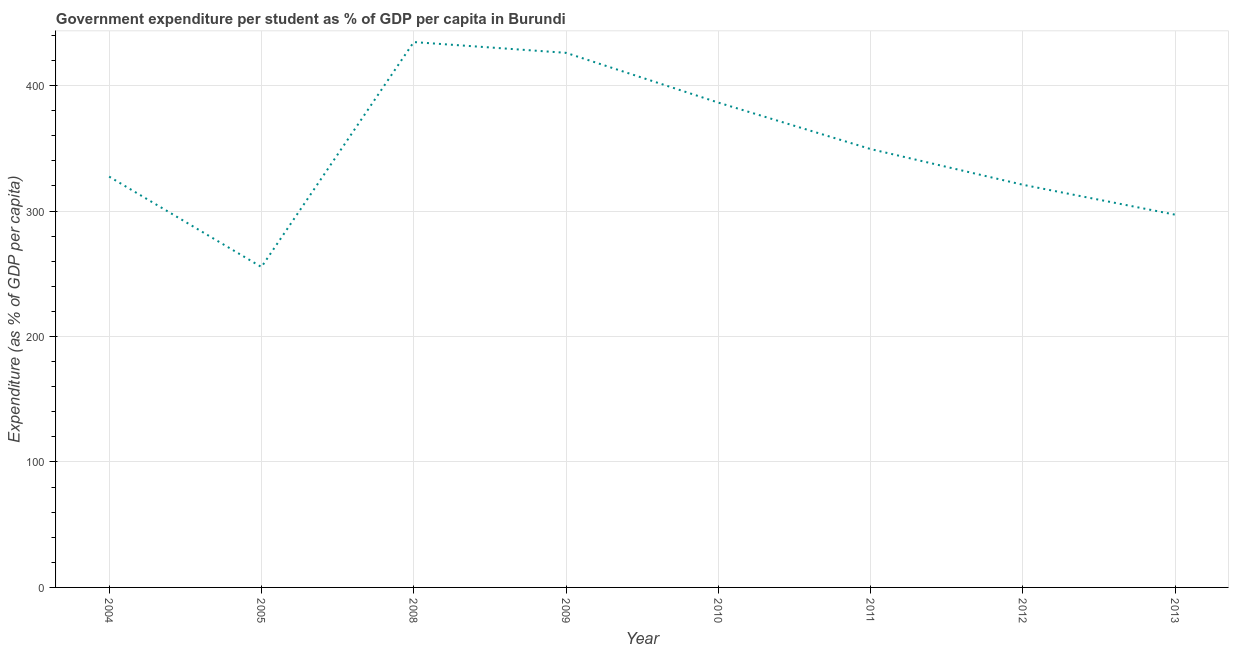What is the government expenditure per student in 2008?
Provide a short and direct response. 434.66. Across all years, what is the maximum government expenditure per student?
Provide a short and direct response. 434.66. Across all years, what is the minimum government expenditure per student?
Provide a succinct answer. 255.38. In which year was the government expenditure per student maximum?
Your answer should be very brief. 2008. In which year was the government expenditure per student minimum?
Give a very brief answer. 2005. What is the sum of the government expenditure per student?
Give a very brief answer. 2797.35. What is the difference between the government expenditure per student in 2008 and 2012?
Keep it short and to the point. 113.75. What is the average government expenditure per student per year?
Ensure brevity in your answer.  349.67. What is the median government expenditure per student?
Give a very brief answer. 338.41. In how many years, is the government expenditure per student greater than 20 %?
Your answer should be very brief. 8. Do a majority of the years between 2013 and 2010 (inclusive) have government expenditure per student greater than 160 %?
Your answer should be very brief. Yes. What is the ratio of the government expenditure per student in 2005 to that in 2008?
Give a very brief answer. 0.59. Is the government expenditure per student in 2004 less than that in 2008?
Give a very brief answer. Yes. Is the difference between the government expenditure per student in 2004 and 2012 greater than the difference between any two years?
Provide a succinct answer. No. What is the difference between the highest and the second highest government expenditure per student?
Your response must be concise. 8.58. What is the difference between the highest and the lowest government expenditure per student?
Your response must be concise. 179.28. In how many years, is the government expenditure per student greater than the average government expenditure per student taken over all years?
Provide a succinct answer. 3. Does the government expenditure per student monotonically increase over the years?
Ensure brevity in your answer.  No. How many years are there in the graph?
Offer a terse response. 8. What is the difference between two consecutive major ticks on the Y-axis?
Keep it short and to the point. 100. Are the values on the major ticks of Y-axis written in scientific E-notation?
Your answer should be very brief. No. Does the graph contain any zero values?
Make the answer very short. No. Does the graph contain grids?
Make the answer very short. Yes. What is the title of the graph?
Ensure brevity in your answer.  Government expenditure per student as % of GDP per capita in Burundi. What is the label or title of the Y-axis?
Your answer should be very brief. Expenditure (as % of GDP per capita). What is the Expenditure (as % of GDP per capita) in 2004?
Your answer should be very brief. 327.42. What is the Expenditure (as % of GDP per capita) of 2005?
Offer a terse response. 255.38. What is the Expenditure (as % of GDP per capita) of 2008?
Your response must be concise. 434.66. What is the Expenditure (as % of GDP per capita) in 2009?
Provide a succinct answer. 426.08. What is the Expenditure (as % of GDP per capita) in 2010?
Provide a succinct answer. 386.42. What is the Expenditure (as % of GDP per capita) in 2011?
Give a very brief answer. 349.39. What is the Expenditure (as % of GDP per capita) of 2012?
Provide a short and direct response. 320.91. What is the Expenditure (as % of GDP per capita) of 2013?
Provide a short and direct response. 297.08. What is the difference between the Expenditure (as % of GDP per capita) in 2004 and 2005?
Provide a short and direct response. 72.04. What is the difference between the Expenditure (as % of GDP per capita) in 2004 and 2008?
Your response must be concise. -107.24. What is the difference between the Expenditure (as % of GDP per capita) in 2004 and 2009?
Ensure brevity in your answer.  -98.66. What is the difference between the Expenditure (as % of GDP per capita) in 2004 and 2010?
Offer a terse response. -59. What is the difference between the Expenditure (as % of GDP per capita) in 2004 and 2011?
Give a very brief answer. -21.96. What is the difference between the Expenditure (as % of GDP per capita) in 2004 and 2012?
Keep it short and to the point. 6.51. What is the difference between the Expenditure (as % of GDP per capita) in 2004 and 2013?
Make the answer very short. 30.34. What is the difference between the Expenditure (as % of GDP per capita) in 2005 and 2008?
Offer a terse response. -179.28. What is the difference between the Expenditure (as % of GDP per capita) in 2005 and 2009?
Your response must be concise. -170.7. What is the difference between the Expenditure (as % of GDP per capita) in 2005 and 2010?
Your answer should be compact. -131.04. What is the difference between the Expenditure (as % of GDP per capita) in 2005 and 2011?
Offer a very short reply. -94.01. What is the difference between the Expenditure (as % of GDP per capita) in 2005 and 2012?
Offer a very short reply. -65.53. What is the difference between the Expenditure (as % of GDP per capita) in 2005 and 2013?
Your response must be concise. -41.7. What is the difference between the Expenditure (as % of GDP per capita) in 2008 and 2009?
Offer a very short reply. 8.58. What is the difference between the Expenditure (as % of GDP per capita) in 2008 and 2010?
Make the answer very short. 48.24. What is the difference between the Expenditure (as % of GDP per capita) in 2008 and 2011?
Ensure brevity in your answer.  85.27. What is the difference between the Expenditure (as % of GDP per capita) in 2008 and 2012?
Keep it short and to the point. 113.75. What is the difference between the Expenditure (as % of GDP per capita) in 2008 and 2013?
Offer a terse response. 137.58. What is the difference between the Expenditure (as % of GDP per capita) in 2009 and 2010?
Provide a short and direct response. 39.66. What is the difference between the Expenditure (as % of GDP per capita) in 2009 and 2011?
Make the answer very short. 76.7. What is the difference between the Expenditure (as % of GDP per capita) in 2009 and 2012?
Give a very brief answer. 105.17. What is the difference between the Expenditure (as % of GDP per capita) in 2009 and 2013?
Make the answer very short. 129. What is the difference between the Expenditure (as % of GDP per capita) in 2010 and 2011?
Keep it short and to the point. 37.03. What is the difference between the Expenditure (as % of GDP per capita) in 2010 and 2012?
Keep it short and to the point. 65.51. What is the difference between the Expenditure (as % of GDP per capita) in 2010 and 2013?
Ensure brevity in your answer.  89.34. What is the difference between the Expenditure (as % of GDP per capita) in 2011 and 2012?
Ensure brevity in your answer.  28.47. What is the difference between the Expenditure (as % of GDP per capita) in 2011 and 2013?
Provide a short and direct response. 52.3. What is the difference between the Expenditure (as % of GDP per capita) in 2012 and 2013?
Your response must be concise. 23.83. What is the ratio of the Expenditure (as % of GDP per capita) in 2004 to that in 2005?
Keep it short and to the point. 1.28. What is the ratio of the Expenditure (as % of GDP per capita) in 2004 to that in 2008?
Your response must be concise. 0.75. What is the ratio of the Expenditure (as % of GDP per capita) in 2004 to that in 2009?
Give a very brief answer. 0.77. What is the ratio of the Expenditure (as % of GDP per capita) in 2004 to that in 2010?
Provide a short and direct response. 0.85. What is the ratio of the Expenditure (as % of GDP per capita) in 2004 to that in 2011?
Offer a terse response. 0.94. What is the ratio of the Expenditure (as % of GDP per capita) in 2004 to that in 2013?
Ensure brevity in your answer.  1.1. What is the ratio of the Expenditure (as % of GDP per capita) in 2005 to that in 2008?
Your answer should be compact. 0.59. What is the ratio of the Expenditure (as % of GDP per capita) in 2005 to that in 2009?
Keep it short and to the point. 0.6. What is the ratio of the Expenditure (as % of GDP per capita) in 2005 to that in 2010?
Your answer should be very brief. 0.66. What is the ratio of the Expenditure (as % of GDP per capita) in 2005 to that in 2011?
Your answer should be very brief. 0.73. What is the ratio of the Expenditure (as % of GDP per capita) in 2005 to that in 2012?
Provide a succinct answer. 0.8. What is the ratio of the Expenditure (as % of GDP per capita) in 2005 to that in 2013?
Your answer should be compact. 0.86. What is the ratio of the Expenditure (as % of GDP per capita) in 2008 to that in 2009?
Ensure brevity in your answer.  1.02. What is the ratio of the Expenditure (as % of GDP per capita) in 2008 to that in 2011?
Provide a short and direct response. 1.24. What is the ratio of the Expenditure (as % of GDP per capita) in 2008 to that in 2012?
Offer a terse response. 1.35. What is the ratio of the Expenditure (as % of GDP per capita) in 2008 to that in 2013?
Your answer should be very brief. 1.46. What is the ratio of the Expenditure (as % of GDP per capita) in 2009 to that in 2010?
Give a very brief answer. 1.1. What is the ratio of the Expenditure (as % of GDP per capita) in 2009 to that in 2011?
Offer a terse response. 1.22. What is the ratio of the Expenditure (as % of GDP per capita) in 2009 to that in 2012?
Provide a short and direct response. 1.33. What is the ratio of the Expenditure (as % of GDP per capita) in 2009 to that in 2013?
Provide a succinct answer. 1.43. What is the ratio of the Expenditure (as % of GDP per capita) in 2010 to that in 2011?
Your response must be concise. 1.11. What is the ratio of the Expenditure (as % of GDP per capita) in 2010 to that in 2012?
Provide a succinct answer. 1.2. What is the ratio of the Expenditure (as % of GDP per capita) in 2010 to that in 2013?
Keep it short and to the point. 1.3. What is the ratio of the Expenditure (as % of GDP per capita) in 2011 to that in 2012?
Make the answer very short. 1.09. What is the ratio of the Expenditure (as % of GDP per capita) in 2011 to that in 2013?
Give a very brief answer. 1.18. 